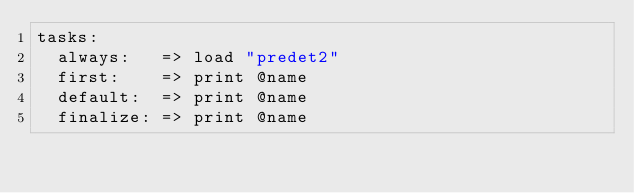<code> <loc_0><loc_0><loc_500><loc_500><_MoonScript_>tasks:
  always:   => load "predet2"
  first:    => print @name
  default:  => print @name
  finalize: => print @name</code> 